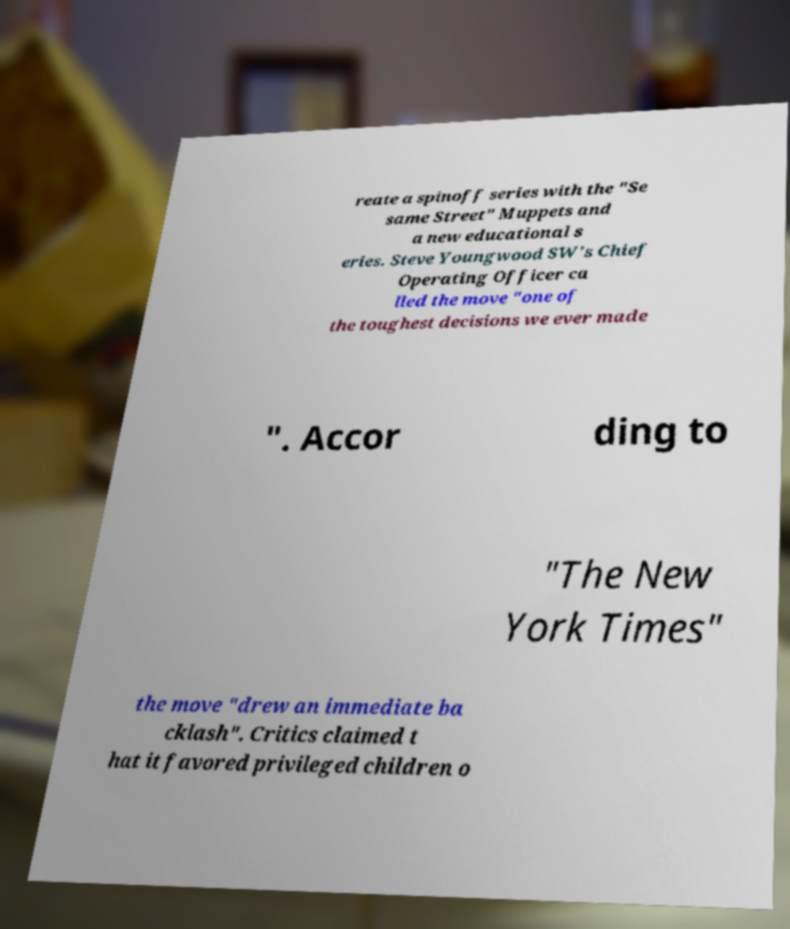Could you extract and type out the text from this image? reate a spinoff series with the "Se same Street" Muppets and a new educational s eries. Steve Youngwood SW's Chief Operating Officer ca lled the move "one of the toughest decisions we ever made ". Accor ding to "The New York Times" the move "drew an immediate ba cklash". Critics claimed t hat it favored privileged children o 